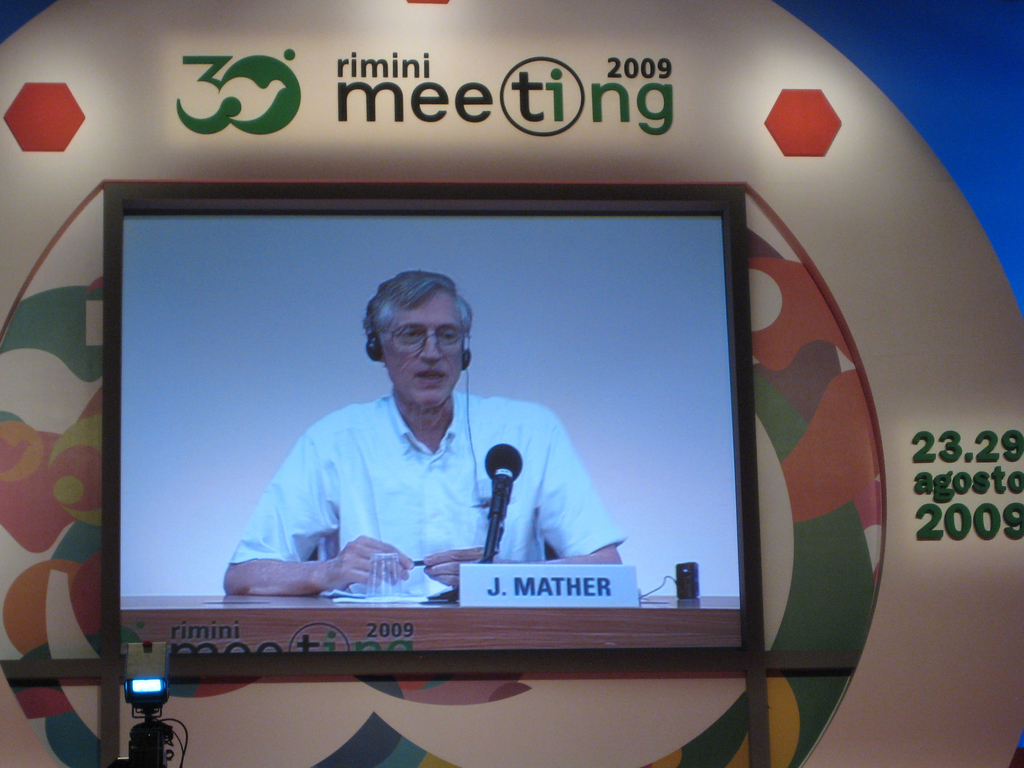Provide a one-sentence caption for the provided image. J. Mather delivers a lecture on astrophysics, engaging with an international audience at the 2009 Rimini Meeting, held from August 23-29, focusing on science and its global implications. 